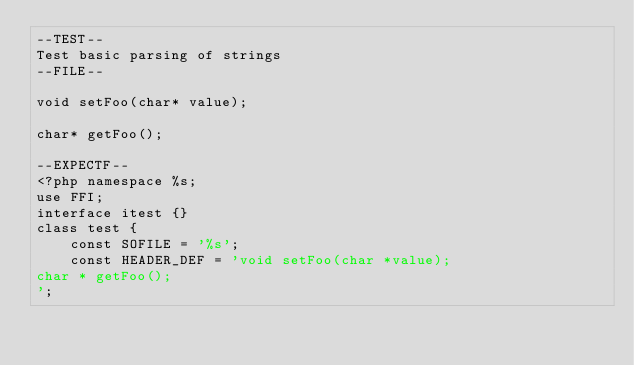<code> <loc_0><loc_0><loc_500><loc_500><_PHP_>--TEST--
Test basic parsing of strings
--FILE--

void setFoo(char* value);

char* getFoo();

--EXPECTF--
<?php namespace %s;
use FFI;
interface itest {}
class test {
    const SOFILE = '%s';
    const HEADER_DEF = 'void setFoo(char *value);
char * getFoo();
';</code> 